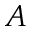<formula> <loc_0><loc_0><loc_500><loc_500>A</formula> 